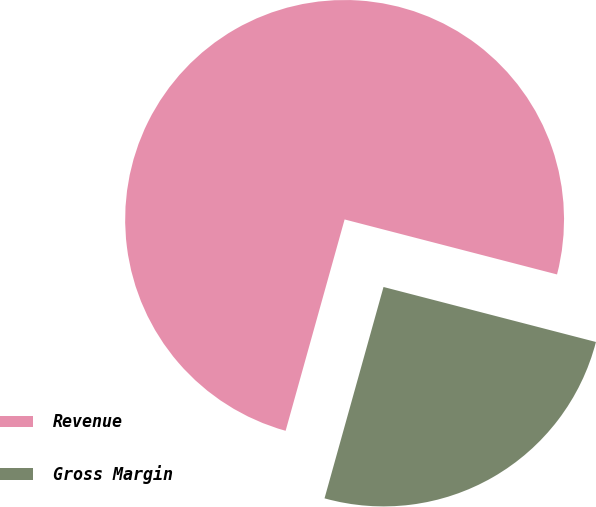<chart> <loc_0><loc_0><loc_500><loc_500><pie_chart><fcel>Revenue<fcel>Gross Margin<nl><fcel>74.7%<fcel>25.3%<nl></chart> 